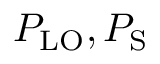Convert formula to latex. <formula><loc_0><loc_0><loc_500><loc_500>P _ { L O } , P _ { S }</formula> 